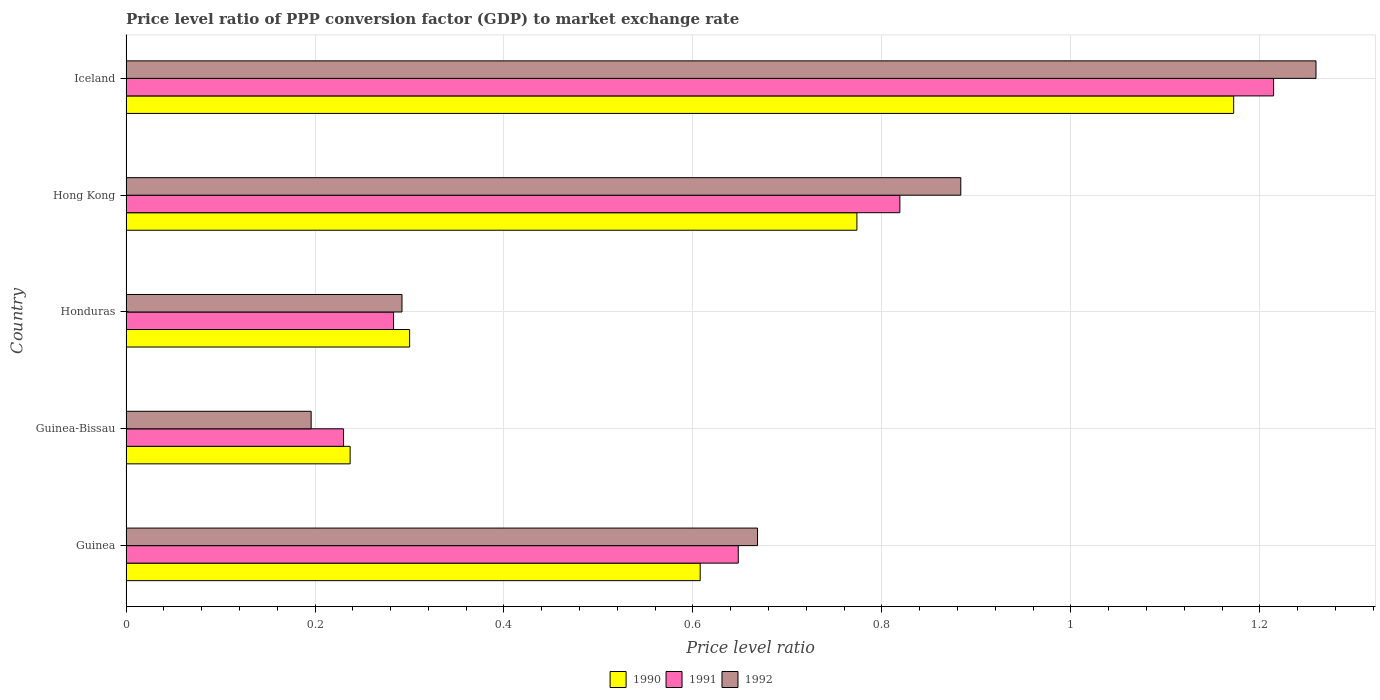Are the number of bars on each tick of the Y-axis equal?
Provide a short and direct response. Yes. How many bars are there on the 2nd tick from the top?
Your answer should be compact. 3. How many bars are there on the 3rd tick from the bottom?
Offer a very short reply. 3. What is the label of the 3rd group of bars from the top?
Your answer should be very brief. Honduras. In how many cases, is the number of bars for a given country not equal to the number of legend labels?
Give a very brief answer. 0. What is the price level ratio in 1992 in Hong Kong?
Offer a terse response. 0.88. Across all countries, what is the maximum price level ratio in 1991?
Provide a succinct answer. 1.21. Across all countries, what is the minimum price level ratio in 1991?
Your response must be concise. 0.23. In which country was the price level ratio in 1991 maximum?
Provide a short and direct response. Iceland. In which country was the price level ratio in 1991 minimum?
Ensure brevity in your answer.  Guinea-Bissau. What is the total price level ratio in 1991 in the graph?
Your answer should be very brief. 3.19. What is the difference between the price level ratio in 1991 in Honduras and that in Iceland?
Ensure brevity in your answer.  -0.93. What is the difference between the price level ratio in 1990 in Honduras and the price level ratio in 1992 in Guinea-Bissau?
Give a very brief answer. 0.1. What is the average price level ratio in 1990 per country?
Ensure brevity in your answer.  0.62. What is the difference between the price level ratio in 1991 and price level ratio in 1992 in Honduras?
Ensure brevity in your answer.  -0.01. In how many countries, is the price level ratio in 1991 greater than 1.2000000000000002 ?
Give a very brief answer. 1. What is the ratio of the price level ratio in 1992 in Guinea to that in Hong Kong?
Give a very brief answer. 0.76. What is the difference between the highest and the second highest price level ratio in 1990?
Your answer should be very brief. 0.4. What is the difference between the highest and the lowest price level ratio in 1991?
Keep it short and to the point. 0.98. Is it the case that in every country, the sum of the price level ratio in 1992 and price level ratio in 1990 is greater than the price level ratio in 1991?
Keep it short and to the point. Yes. How many bars are there?
Your answer should be compact. 15. Are all the bars in the graph horizontal?
Make the answer very short. Yes. Are the values on the major ticks of X-axis written in scientific E-notation?
Ensure brevity in your answer.  No. Does the graph contain any zero values?
Your answer should be very brief. No. How many legend labels are there?
Your response must be concise. 3. How are the legend labels stacked?
Your answer should be compact. Horizontal. What is the title of the graph?
Give a very brief answer. Price level ratio of PPP conversion factor (GDP) to market exchange rate. What is the label or title of the X-axis?
Your answer should be very brief. Price level ratio. What is the Price level ratio of 1990 in Guinea?
Ensure brevity in your answer.  0.61. What is the Price level ratio of 1991 in Guinea?
Your response must be concise. 0.65. What is the Price level ratio in 1992 in Guinea?
Offer a terse response. 0.67. What is the Price level ratio of 1990 in Guinea-Bissau?
Provide a succinct answer. 0.24. What is the Price level ratio in 1991 in Guinea-Bissau?
Ensure brevity in your answer.  0.23. What is the Price level ratio of 1992 in Guinea-Bissau?
Give a very brief answer. 0.2. What is the Price level ratio of 1990 in Honduras?
Give a very brief answer. 0.3. What is the Price level ratio of 1991 in Honduras?
Your answer should be very brief. 0.28. What is the Price level ratio of 1992 in Honduras?
Your answer should be compact. 0.29. What is the Price level ratio in 1990 in Hong Kong?
Your answer should be compact. 0.77. What is the Price level ratio in 1991 in Hong Kong?
Provide a short and direct response. 0.82. What is the Price level ratio in 1992 in Hong Kong?
Your answer should be very brief. 0.88. What is the Price level ratio of 1990 in Iceland?
Your answer should be very brief. 1.17. What is the Price level ratio of 1991 in Iceland?
Offer a terse response. 1.21. What is the Price level ratio of 1992 in Iceland?
Ensure brevity in your answer.  1.26. Across all countries, what is the maximum Price level ratio in 1990?
Ensure brevity in your answer.  1.17. Across all countries, what is the maximum Price level ratio of 1991?
Keep it short and to the point. 1.21. Across all countries, what is the maximum Price level ratio of 1992?
Your answer should be very brief. 1.26. Across all countries, what is the minimum Price level ratio of 1990?
Give a very brief answer. 0.24. Across all countries, what is the minimum Price level ratio of 1991?
Offer a very short reply. 0.23. Across all countries, what is the minimum Price level ratio in 1992?
Keep it short and to the point. 0.2. What is the total Price level ratio of 1990 in the graph?
Provide a short and direct response. 3.09. What is the total Price level ratio in 1991 in the graph?
Provide a short and direct response. 3.19. What is the total Price level ratio in 1992 in the graph?
Offer a terse response. 3.3. What is the difference between the Price level ratio of 1990 in Guinea and that in Guinea-Bissau?
Offer a very short reply. 0.37. What is the difference between the Price level ratio of 1991 in Guinea and that in Guinea-Bissau?
Offer a terse response. 0.42. What is the difference between the Price level ratio in 1992 in Guinea and that in Guinea-Bissau?
Give a very brief answer. 0.47. What is the difference between the Price level ratio in 1990 in Guinea and that in Honduras?
Provide a short and direct response. 0.31. What is the difference between the Price level ratio of 1991 in Guinea and that in Honduras?
Your answer should be compact. 0.36. What is the difference between the Price level ratio of 1992 in Guinea and that in Honduras?
Provide a short and direct response. 0.38. What is the difference between the Price level ratio in 1990 in Guinea and that in Hong Kong?
Make the answer very short. -0.17. What is the difference between the Price level ratio in 1991 in Guinea and that in Hong Kong?
Offer a very short reply. -0.17. What is the difference between the Price level ratio of 1992 in Guinea and that in Hong Kong?
Provide a short and direct response. -0.22. What is the difference between the Price level ratio in 1990 in Guinea and that in Iceland?
Provide a short and direct response. -0.56. What is the difference between the Price level ratio in 1991 in Guinea and that in Iceland?
Give a very brief answer. -0.57. What is the difference between the Price level ratio of 1992 in Guinea and that in Iceland?
Make the answer very short. -0.59. What is the difference between the Price level ratio in 1990 in Guinea-Bissau and that in Honduras?
Your answer should be very brief. -0.06. What is the difference between the Price level ratio of 1991 in Guinea-Bissau and that in Honduras?
Provide a short and direct response. -0.05. What is the difference between the Price level ratio in 1992 in Guinea-Bissau and that in Honduras?
Offer a terse response. -0.1. What is the difference between the Price level ratio of 1990 in Guinea-Bissau and that in Hong Kong?
Offer a very short reply. -0.54. What is the difference between the Price level ratio in 1991 in Guinea-Bissau and that in Hong Kong?
Ensure brevity in your answer.  -0.59. What is the difference between the Price level ratio of 1992 in Guinea-Bissau and that in Hong Kong?
Give a very brief answer. -0.69. What is the difference between the Price level ratio of 1990 in Guinea-Bissau and that in Iceland?
Your answer should be very brief. -0.94. What is the difference between the Price level ratio in 1991 in Guinea-Bissau and that in Iceland?
Give a very brief answer. -0.98. What is the difference between the Price level ratio in 1992 in Guinea-Bissau and that in Iceland?
Your response must be concise. -1.06. What is the difference between the Price level ratio of 1990 in Honduras and that in Hong Kong?
Your answer should be very brief. -0.47. What is the difference between the Price level ratio of 1991 in Honduras and that in Hong Kong?
Your response must be concise. -0.54. What is the difference between the Price level ratio in 1992 in Honduras and that in Hong Kong?
Your answer should be very brief. -0.59. What is the difference between the Price level ratio of 1990 in Honduras and that in Iceland?
Give a very brief answer. -0.87. What is the difference between the Price level ratio in 1991 in Honduras and that in Iceland?
Make the answer very short. -0.93. What is the difference between the Price level ratio in 1992 in Honduras and that in Iceland?
Give a very brief answer. -0.97. What is the difference between the Price level ratio in 1990 in Hong Kong and that in Iceland?
Your response must be concise. -0.4. What is the difference between the Price level ratio in 1991 in Hong Kong and that in Iceland?
Your response must be concise. -0.4. What is the difference between the Price level ratio of 1992 in Hong Kong and that in Iceland?
Offer a terse response. -0.38. What is the difference between the Price level ratio in 1990 in Guinea and the Price level ratio in 1991 in Guinea-Bissau?
Offer a terse response. 0.38. What is the difference between the Price level ratio of 1990 in Guinea and the Price level ratio of 1992 in Guinea-Bissau?
Your answer should be very brief. 0.41. What is the difference between the Price level ratio in 1991 in Guinea and the Price level ratio in 1992 in Guinea-Bissau?
Keep it short and to the point. 0.45. What is the difference between the Price level ratio of 1990 in Guinea and the Price level ratio of 1991 in Honduras?
Ensure brevity in your answer.  0.32. What is the difference between the Price level ratio in 1990 in Guinea and the Price level ratio in 1992 in Honduras?
Provide a succinct answer. 0.32. What is the difference between the Price level ratio in 1991 in Guinea and the Price level ratio in 1992 in Honduras?
Your answer should be compact. 0.36. What is the difference between the Price level ratio in 1990 in Guinea and the Price level ratio in 1991 in Hong Kong?
Offer a very short reply. -0.21. What is the difference between the Price level ratio of 1990 in Guinea and the Price level ratio of 1992 in Hong Kong?
Make the answer very short. -0.28. What is the difference between the Price level ratio in 1991 in Guinea and the Price level ratio in 1992 in Hong Kong?
Offer a very short reply. -0.24. What is the difference between the Price level ratio in 1990 in Guinea and the Price level ratio in 1991 in Iceland?
Your answer should be very brief. -0.61. What is the difference between the Price level ratio in 1990 in Guinea and the Price level ratio in 1992 in Iceland?
Offer a terse response. -0.65. What is the difference between the Price level ratio of 1991 in Guinea and the Price level ratio of 1992 in Iceland?
Offer a very short reply. -0.61. What is the difference between the Price level ratio in 1990 in Guinea-Bissau and the Price level ratio in 1991 in Honduras?
Give a very brief answer. -0.05. What is the difference between the Price level ratio of 1990 in Guinea-Bissau and the Price level ratio of 1992 in Honduras?
Offer a terse response. -0.05. What is the difference between the Price level ratio of 1991 in Guinea-Bissau and the Price level ratio of 1992 in Honduras?
Ensure brevity in your answer.  -0.06. What is the difference between the Price level ratio of 1990 in Guinea-Bissau and the Price level ratio of 1991 in Hong Kong?
Give a very brief answer. -0.58. What is the difference between the Price level ratio of 1990 in Guinea-Bissau and the Price level ratio of 1992 in Hong Kong?
Provide a succinct answer. -0.65. What is the difference between the Price level ratio of 1991 in Guinea-Bissau and the Price level ratio of 1992 in Hong Kong?
Ensure brevity in your answer.  -0.65. What is the difference between the Price level ratio in 1990 in Guinea-Bissau and the Price level ratio in 1991 in Iceland?
Give a very brief answer. -0.98. What is the difference between the Price level ratio in 1990 in Guinea-Bissau and the Price level ratio in 1992 in Iceland?
Ensure brevity in your answer.  -1.02. What is the difference between the Price level ratio in 1991 in Guinea-Bissau and the Price level ratio in 1992 in Iceland?
Offer a terse response. -1.03. What is the difference between the Price level ratio of 1990 in Honduras and the Price level ratio of 1991 in Hong Kong?
Provide a succinct answer. -0.52. What is the difference between the Price level ratio in 1990 in Honduras and the Price level ratio in 1992 in Hong Kong?
Make the answer very short. -0.58. What is the difference between the Price level ratio of 1991 in Honduras and the Price level ratio of 1992 in Hong Kong?
Make the answer very short. -0.6. What is the difference between the Price level ratio in 1990 in Honduras and the Price level ratio in 1991 in Iceland?
Give a very brief answer. -0.91. What is the difference between the Price level ratio of 1990 in Honduras and the Price level ratio of 1992 in Iceland?
Make the answer very short. -0.96. What is the difference between the Price level ratio of 1991 in Honduras and the Price level ratio of 1992 in Iceland?
Ensure brevity in your answer.  -0.98. What is the difference between the Price level ratio in 1990 in Hong Kong and the Price level ratio in 1991 in Iceland?
Provide a succinct answer. -0.44. What is the difference between the Price level ratio of 1990 in Hong Kong and the Price level ratio of 1992 in Iceland?
Your response must be concise. -0.49. What is the difference between the Price level ratio in 1991 in Hong Kong and the Price level ratio in 1992 in Iceland?
Ensure brevity in your answer.  -0.44. What is the average Price level ratio in 1990 per country?
Provide a short and direct response. 0.62. What is the average Price level ratio of 1991 per country?
Ensure brevity in your answer.  0.64. What is the average Price level ratio in 1992 per country?
Provide a succinct answer. 0.66. What is the difference between the Price level ratio of 1990 and Price level ratio of 1991 in Guinea?
Your answer should be very brief. -0.04. What is the difference between the Price level ratio in 1990 and Price level ratio in 1992 in Guinea?
Make the answer very short. -0.06. What is the difference between the Price level ratio of 1991 and Price level ratio of 1992 in Guinea?
Ensure brevity in your answer.  -0.02. What is the difference between the Price level ratio in 1990 and Price level ratio in 1991 in Guinea-Bissau?
Offer a very short reply. 0.01. What is the difference between the Price level ratio in 1990 and Price level ratio in 1992 in Guinea-Bissau?
Offer a terse response. 0.04. What is the difference between the Price level ratio in 1991 and Price level ratio in 1992 in Guinea-Bissau?
Provide a short and direct response. 0.03. What is the difference between the Price level ratio of 1990 and Price level ratio of 1991 in Honduras?
Make the answer very short. 0.02. What is the difference between the Price level ratio in 1990 and Price level ratio in 1992 in Honduras?
Your answer should be compact. 0.01. What is the difference between the Price level ratio in 1991 and Price level ratio in 1992 in Honduras?
Offer a very short reply. -0.01. What is the difference between the Price level ratio of 1990 and Price level ratio of 1991 in Hong Kong?
Give a very brief answer. -0.05. What is the difference between the Price level ratio of 1990 and Price level ratio of 1992 in Hong Kong?
Offer a terse response. -0.11. What is the difference between the Price level ratio of 1991 and Price level ratio of 1992 in Hong Kong?
Provide a succinct answer. -0.06. What is the difference between the Price level ratio of 1990 and Price level ratio of 1991 in Iceland?
Keep it short and to the point. -0.04. What is the difference between the Price level ratio in 1990 and Price level ratio in 1992 in Iceland?
Give a very brief answer. -0.09. What is the difference between the Price level ratio of 1991 and Price level ratio of 1992 in Iceland?
Offer a terse response. -0.04. What is the ratio of the Price level ratio in 1990 in Guinea to that in Guinea-Bissau?
Make the answer very short. 2.56. What is the ratio of the Price level ratio of 1991 in Guinea to that in Guinea-Bissau?
Give a very brief answer. 2.81. What is the ratio of the Price level ratio of 1992 in Guinea to that in Guinea-Bissau?
Offer a terse response. 3.41. What is the ratio of the Price level ratio in 1990 in Guinea to that in Honduras?
Ensure brevity in your answer.  2.02. What is the ratio of the Price level ratio of 1991 in Guinea to that in Honduras?
Make the answer very short. 2.29. What is the ratio of the Price level ratio of 1992 in Guinea to that in Honduras?
Your response must be concise. 2.29. What is the ratio of the Price level ratio in 1990 in Guinea to that in Hong Kong?
Provide a short and direct response. 0.79. What is the ratio of the Price level ratio in 1991 in Guinea to that in Hong Kong?
Offer a terse response. 0.79. What is the ratio of the Price level ratio of 1992 in Guinea to that in Hong Kong?
Provide a short and direct response. 0.76. What is the ratio of the Price level ratio in 1990 in Guinea to that in Iceland?
Provide a short and direct response. 0.52. What is the ratio of the Price level ratio in 1991 in Guinea to that in Iceland?
Offer a very short reply. 0.53. What is the ratio of the Price level ratio of 1992 in Guinea to that in Iceland?
Your answer should be compact. 0.53. What is the ratio of the Price level ratio in 1990 in Guinea-Bissau to that in Honduras?
Your response must be concise. 0.79. What is the ratio of the Price level ratio of 1991 in Guinea-Bissau to that in Honduras?
Provide a succinct answer. 0.81. What is the ratio of the Price level ratio in 1992 in Guinea-Bissau to that in Honduras?
Offer a terse response. 0.67. What is the ratio of the Price level ratio of 1990 in Guinea-Bissau to that in Hong Kong?
Ensure brevity in your answer.  0.31. What is the ratio of the Price level ratio in 1991 in Guinea-Bissau to that in Hong Kong?
Your answer should be very brief. 0.28. What is the ratio of the Price level ratio of 1992 in Guinea-Bissau to that in Hong Kong?
Make the answer very short. 0.22. What is the ratio of the Price level ratio in 1990 in Guinea-Bissau to that in Iceland?
Your answer should be compact. 0.2. What is the ratio of the Price level ratio in 1991 in Guinea-Bissau to that in Iceland?
Provide a succinct answer. 0.19. What is the ratio of the Price level ratio of 1992 in Guinea-Bissau to that in Iceland?
Provide a succinct answer. 0.16. What is the ratio of the Price level ratio of 1990 in Honduras to that in Hong Kong?
Your answer should be very brief. 0.39. What is the ratio of the Price level ratio in 1991 in Honduras to that in Hong Kong?
Make the answer very short. 0.35. What is the ratio of the Price level ratio of 1992 in Honduras to that in Hong Kong?
Ensure brevity in your answer.  0.33. What is the ratio of the Price level ratio of 1990 in Honduras to that in Iceland?
Your answer should be very brief. 0.26. What is the ratio of the Price level ratio of 1991 in Honduras to that in Iceland?
Provide a succinct answer. 0.23. What is the ratio of the Price level ratio of 1992 in Honduras to that in Iceland?
Give a very brief answer. 0.23. What is the ratio of the Price level ratio of 1990 in Hong Kong to that in Iceland?
Ensure brevity in your answer.  0.66. What is the ratio of the Price level ratio of 1991 in Hong Kong to that in Iceland?
Provide a short and direct response. 0.67. What is the ratio of the Price level ratio of 1992 in Hong Kong to that in Iceland?
Give a very brief answer. 0.7. What is the difference between the highest and the second highest Price level ratio of 1990?
Provide a succinct answer. 0.4. What is the difference between the highest and the second highest Price level ratio in 1991?
Provide a succinct answer. 0.4. What is the difference between the highest and the second highest Price level ratio of 1992?
Ensure brevity in your answer.  0.38. What is the difference between the highest and the lowest Price level ratio in 1990?
Offer a terse response. 0.94. What is the difference between the highest and the lowest Price level ratio in 1991?
Provide a succinct answer. 0.98. What is the difference between the highest and the lowest Price level ratio in 1992?
Your answer should be compact. 1.06. 